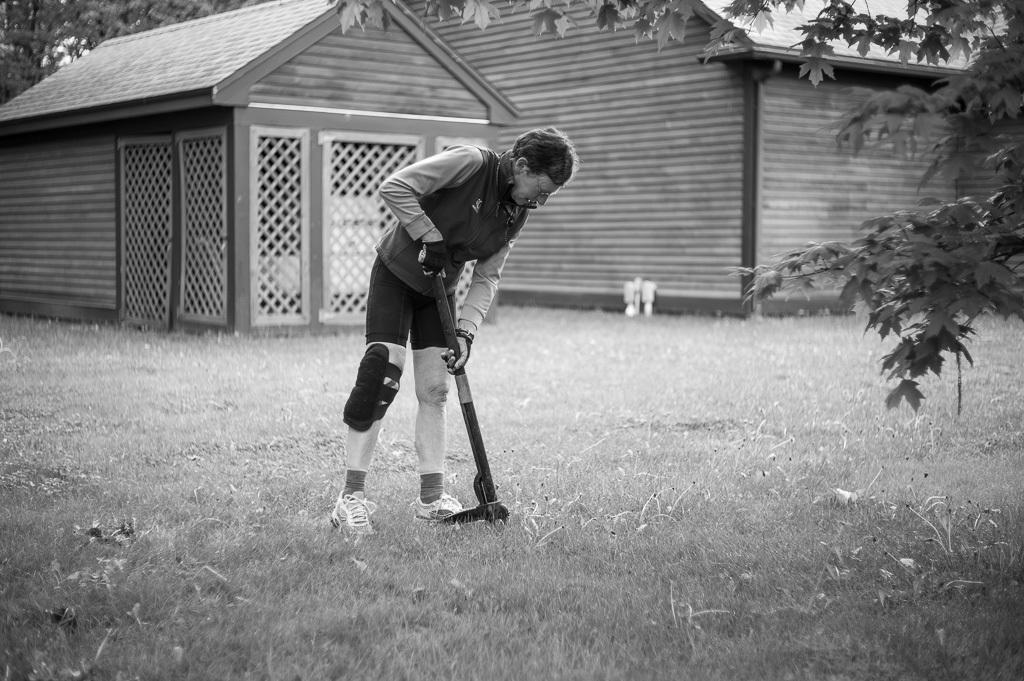Who is present in the image? There is a man in the image. What is the man doing in the image? The man is standing and holding a grass cutting machine. What can be seen in the background of the image? There are houses and trees in the background of the image. What advice is the man giving to the trees in the image? There is no indication in the image that the man is giving advice to the trees, as he is holding a grass cutting machine and not interacting with the trees. 